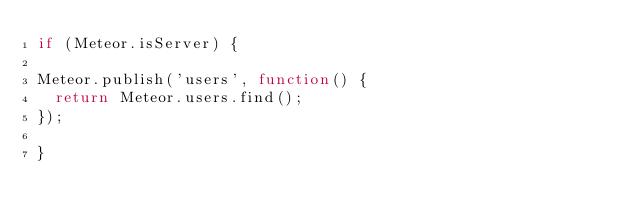<code> <loc_0><loc_0><loc_500><loc_500><_JavaScript_>if (Meteor.isServer) {

Meteor.publish('users', function() {
	return Meteor.users.find();
});

}
</code> 